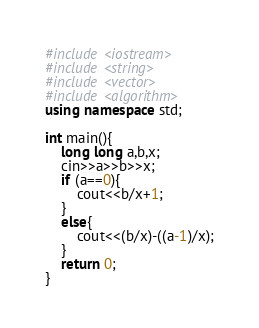<code> <loc_0><loc_0><loc_500><loc_500><_C++_>#include <iostream>
#include <string>
#include <vector>
#include <algorithm>
using namespace std;

int main(){
    long long a,b,x;
    cin>>a>>b>>x;
    if (a==0){
        cout<<b/x+1;
    }
    else{
        cout<<(b/x)-((a-1)/x);
    }
    return 0;
}</code> 